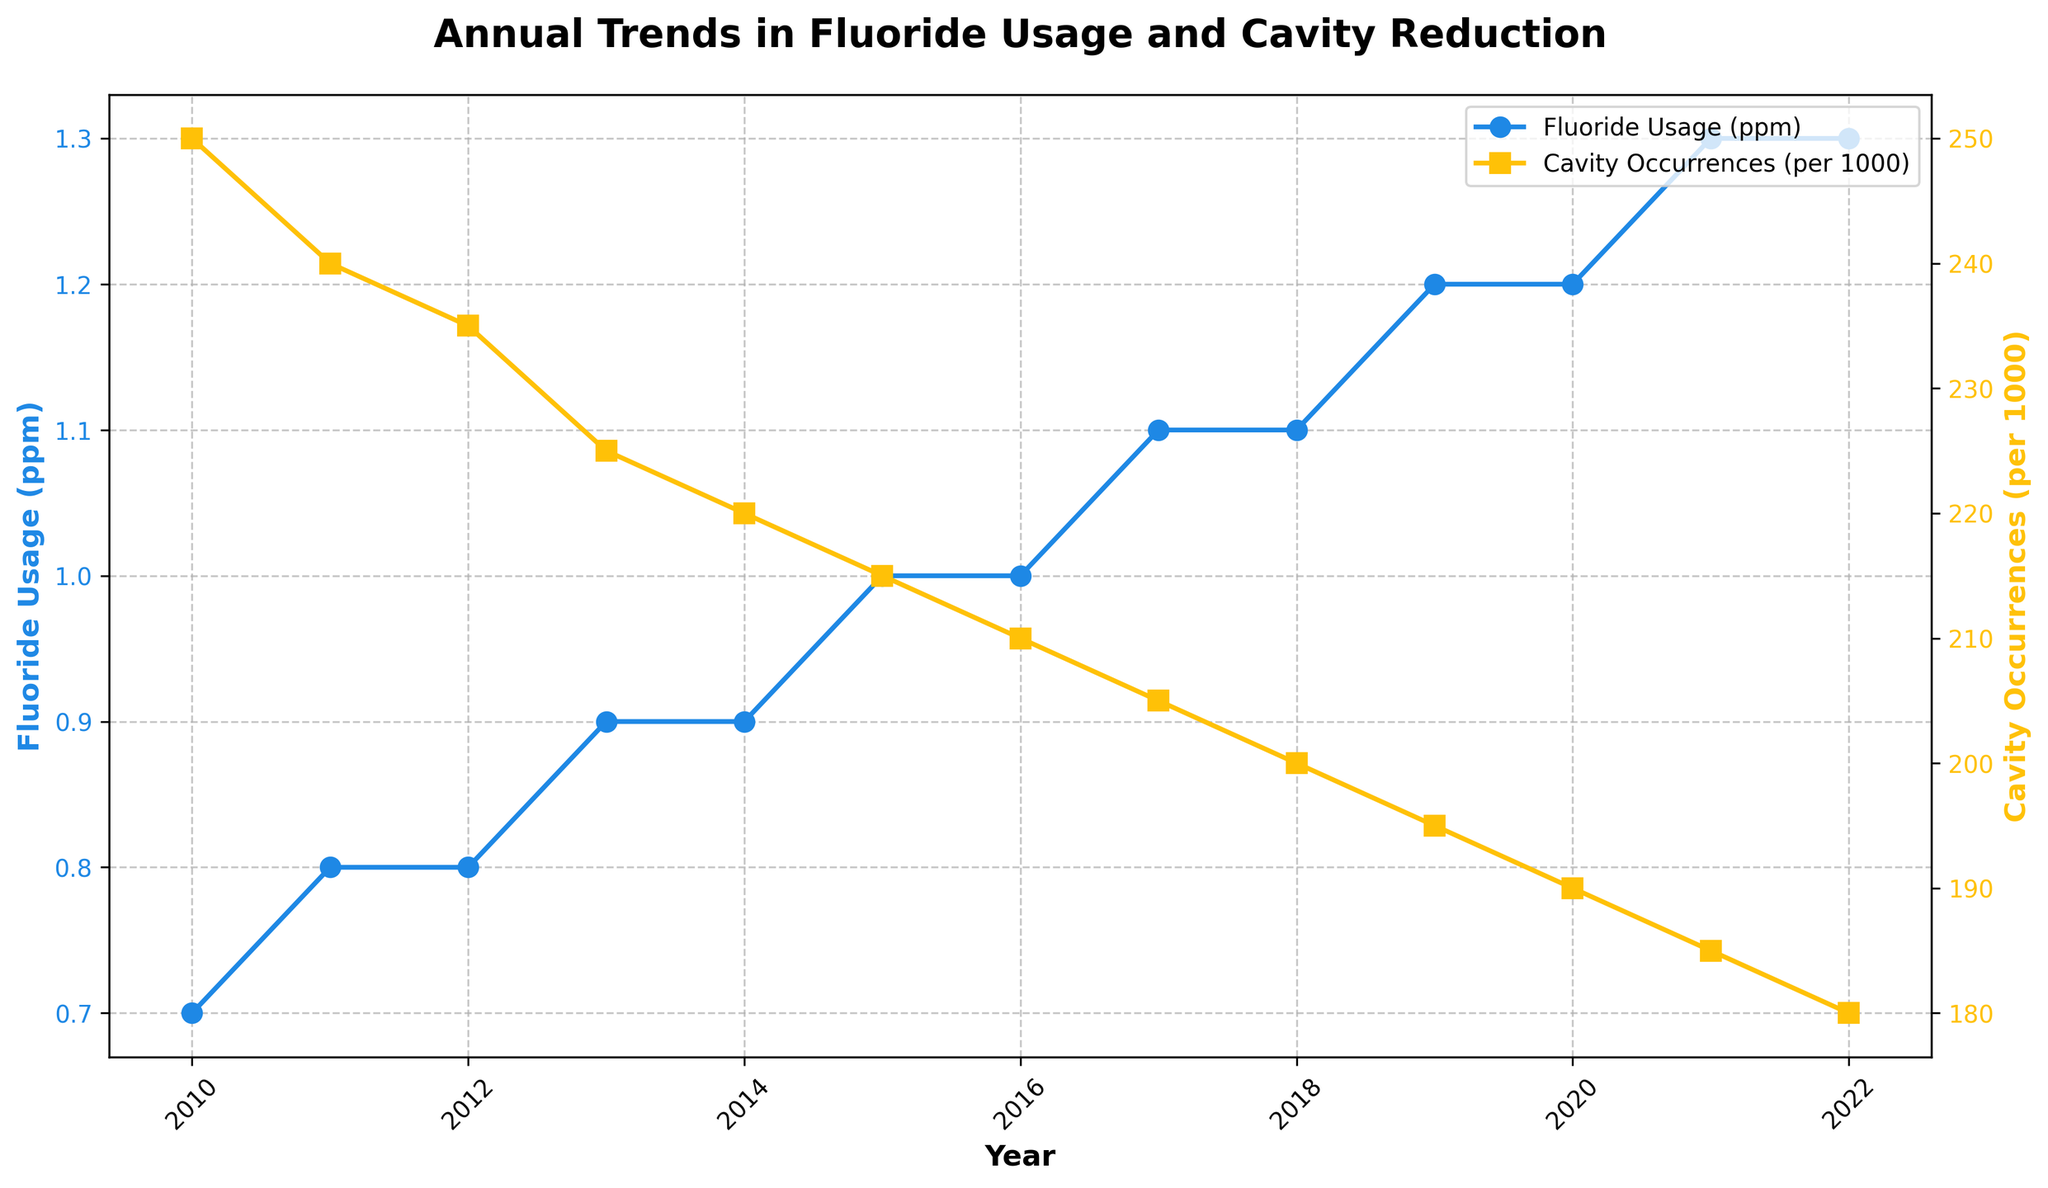How many years are displayed in the plot? Count the number of data points on the x-axis representing the years. From 2010 to 2022, a total of 13 years are displayed.
Answer: 13 What trend do you see in Fluoride Usage from 2010 to 2022? Observe the direction and pattern of the line representing 'Fluoride Usage (ppm)' on the left y-axis. The trend shows a consistent increase in Fluoride Usage over the years.
Answer: Increasing In which year were Cavity Occurrences the lowest? Identify the lowest point on the line representing 'Cavity Occurrences (per 1000)' on the right y-axis. The lowest point occurs in 2022.
Answer: 2022 What is the difference in Cavity Occurrences between 2010 and 2022? Note the values on the 'Cavity Occurrences (per 1000)' line for 2010 (250) and 2022 (180). Subtract 180 from 250 to find the difference. 250 - 180 = 70
Answer: 70 What is the relationship between Fluoride Usage and Cavity Occurrences? Observe how the two lines representing 'Fluoride Usage (ppm)' and 'Cavity Occurrences (per 1000)' change over time. As Fluoride Usage increases, Cavity Occurrences decrease.
Answer: Inverse relationship By how much did Fluoride Usage increase from 2010 to 2022? Note the values on the 'Fluoride Usage (ppm)' line for 2010 (0.7 ppm) and 2022 (1.3 ppm). Subtract 0.7 from 1.3 to find the increase. 1.3 - 0.7 = 0.6 ppm
Answer: 0.6 ppm Which year had the most significant decrease in Cavity Occurrences compared to the previous year? Calculate the year-to-year differences in Cavity Occurrences. The biggest decrease is from 2010 (250) to 2011 (240), a reduction of 10 per 1000.
Answer: 2010 to 2011 Between which two consecutive years did Fluoride Usage increase the most? Calculate the year-to-year differences in Fluoride Usage. The largest increase is between 2020 (1.2 ppm) and 2021 (1.3 ppm), an increase of 0.1 ppm.
Answer: 2020 to 2021 How did Cavity Occurrences trend over the entire period? Notice the general direction and pattern of the line representing 'Cavity Occurrences (per 1000)'. The trend shows a consistent decrease over the years.
Answer: Decreasing 